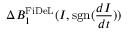<formula> <loc_0><loc_0><loc_500><loc_500>\Delta B _ { 1 } ^ { F i D e L } ( I , s g n ( \frac { d I } { d t } ) )</formula> 